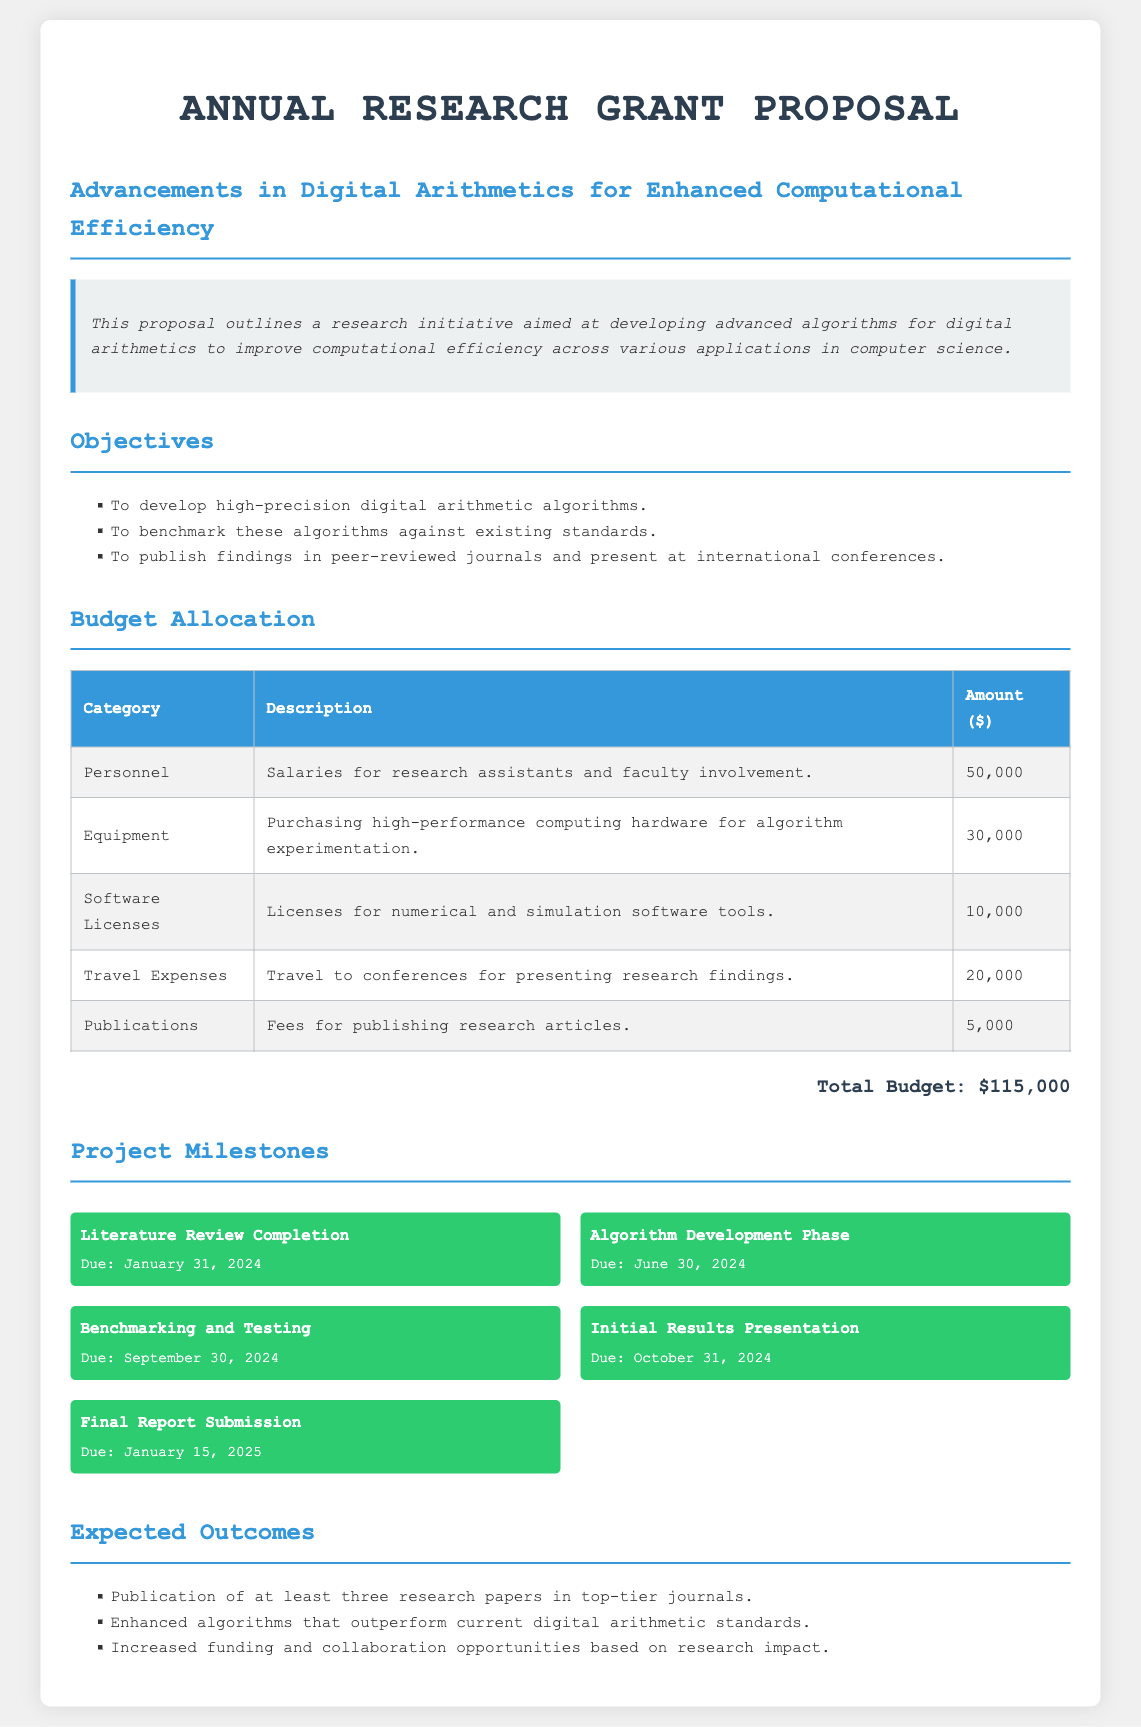what is the total budget? The total budget is presented at the end of the budget allocation section, totaling $115,000.
Answer: $115,000 what is the due date for the literature review completion? This information is provided in the project milestones section, stating the deadline is January 31, 2024.
Answer: January 31, 2024 how much is allocated for travel expenses? Travel expenses are listed in the budget table with an allocated amount of $20,000.
Answer: $20,000 what is one of the objectives of the proposal? The proposal outlines its objectives in the objectives section, where it states the aim to develop high-precision digital arithmetic algorithms.
Answer: Develop high-precision digital arithmetic algorithms how many research papers are expected to be published? The expected outcomes section mentions the goal of publishing at least three research papers in top-tier journals.
Answer: Three what category has the highest budget allocation? By analyzing the budget table, the category with the highest allocation is Personnel with $50,000.
Answer: Personnel what is the purpose of the proposed research initiative? The introduction section states that the initiative aims to improve computational efficiency across various applications in computer science.
Answer: Improve computational efficiency when is the final report submission due? The project milestones section indicates that the final report submission is due on January 15, 2025.
Answer: January 15, 2025 